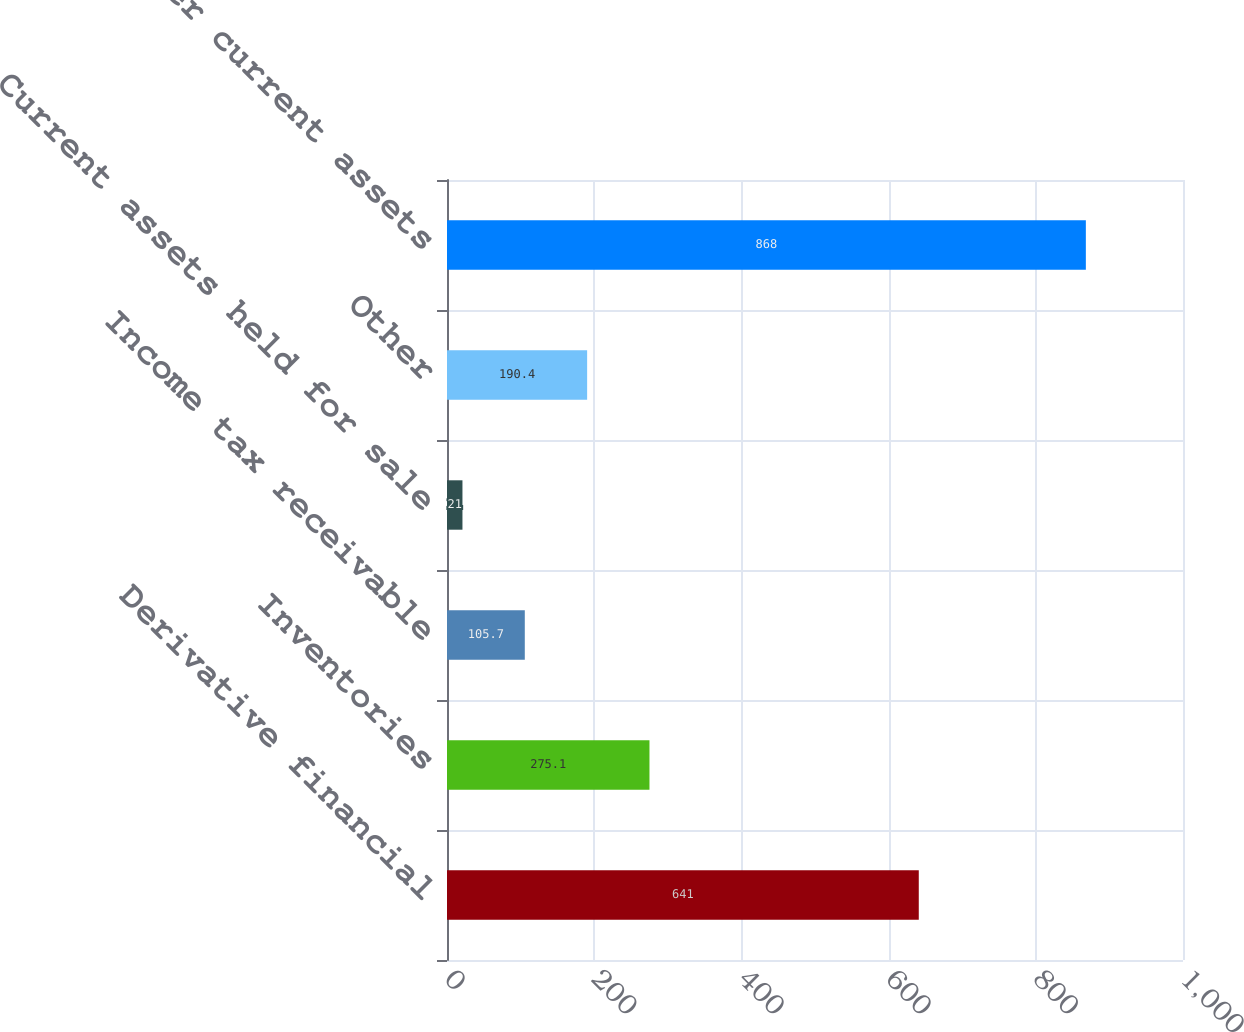Convert chart. <chart><loc_0><loc_0><loc_500><loc_500><bar_chart><fcel>Derivative financial<fcel>Inventories<fcel>Income tax receivable<fcel>Current assets held for sale<fcel>Other<fcel>Other current assets<nl><fcel>641<fcel>275.1<fcel>105.7<fcel>21<fcel>190.4<fcel>868<nl></chart> 